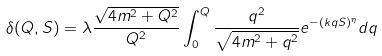<formula> <loc_0><loc_0><loc_500><loc_500>\delta ( Q , S ) = \lambda \frac { \sqrt { 4 m ^ { 2 } + Q ^ { 2 } } } { Q ^ { 2 } } \int ^ { Q } _ { 0 } \frac { q ^ { 2 } } { \sqrt { 4 m ^ { 2 } + q ^ { 2 } } } e ^ { - ( k q S ) ^ { \eta } } d q</formula> 